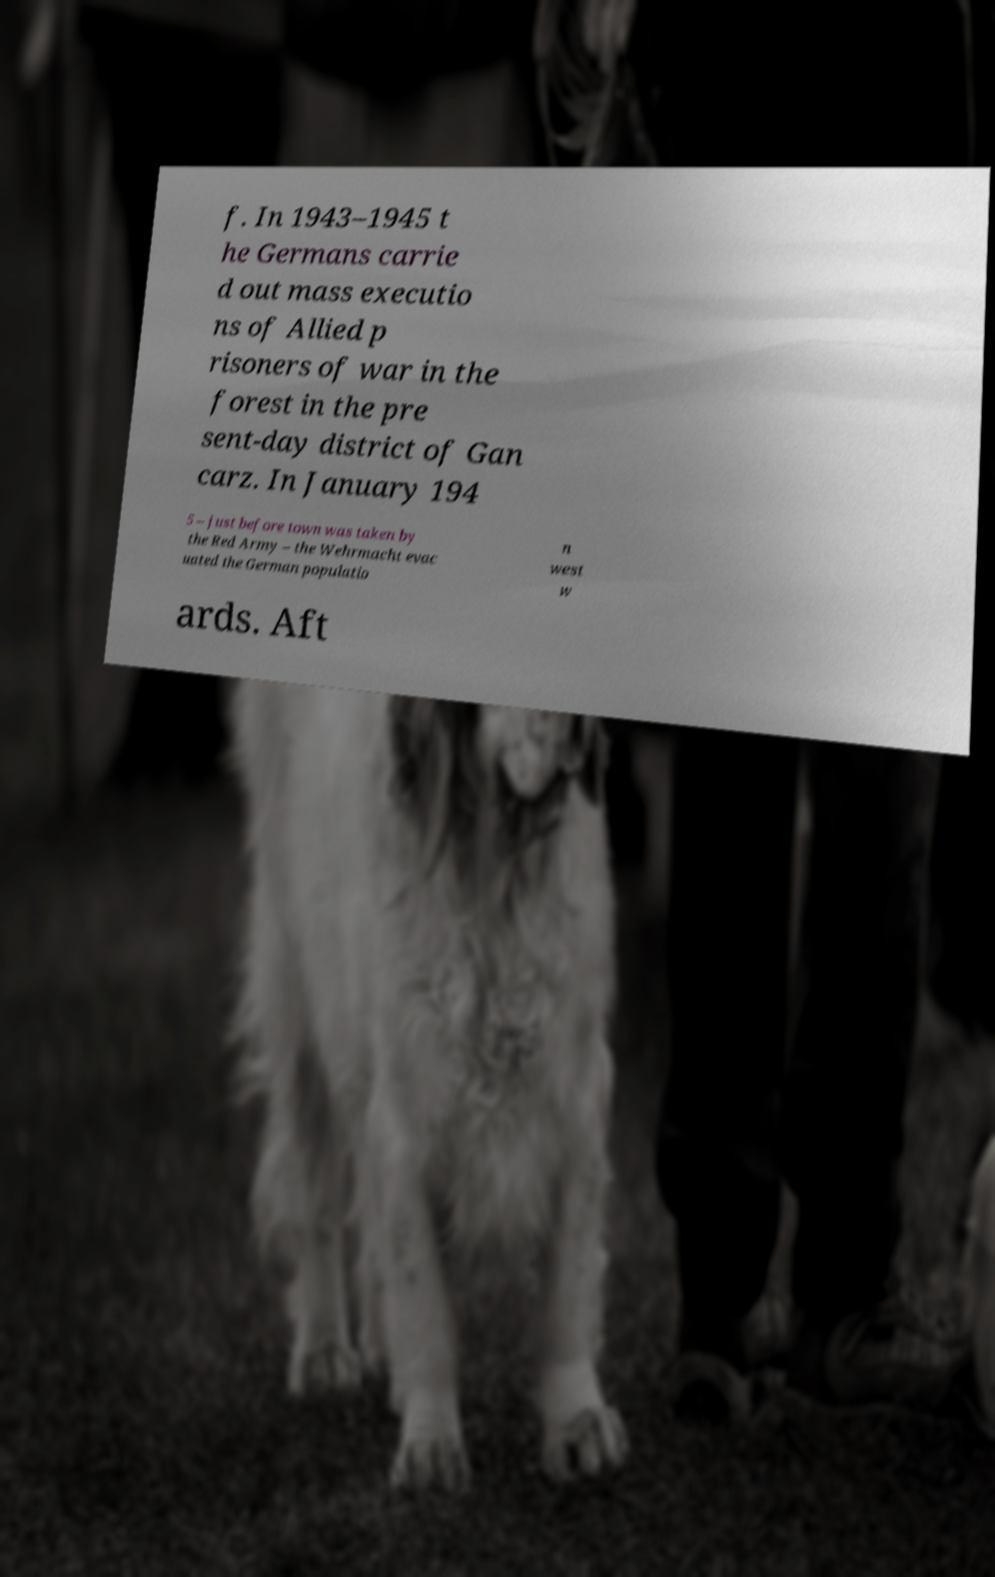Can you read and provide the text displayed in the image?This photo seems to have some interesting text. Can you extract and type it out for me? f. In 1943–1945 t he Germans carrie d out mass executio ns of Allied p risoners of war in the forest in the pre sent-day district of Gan carz. In January 194 5 – just before town was taken by the Red Army – the Wehrmacht evac uated the German populatio n west w ards. Aft 